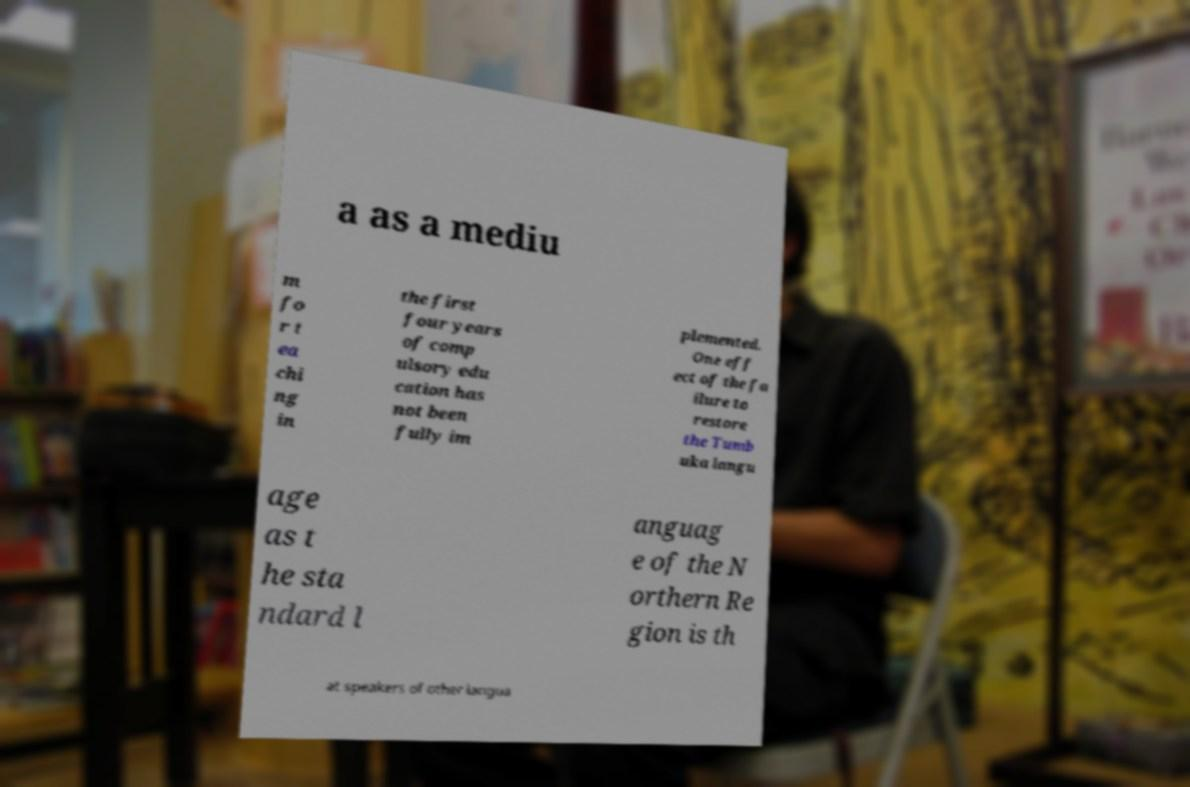Could you assist in decoding the text presented in this image and type it out clearly? a as a mediu m fo r t ea chi ng in the first four years of comp ulsory edu cation has not been fully im plemented. One eff ect of the fa ilure to restore the Tumb uka langu age as t he sta ndard l anguag e of the N orthern Re gion is th at speakers of other langua 